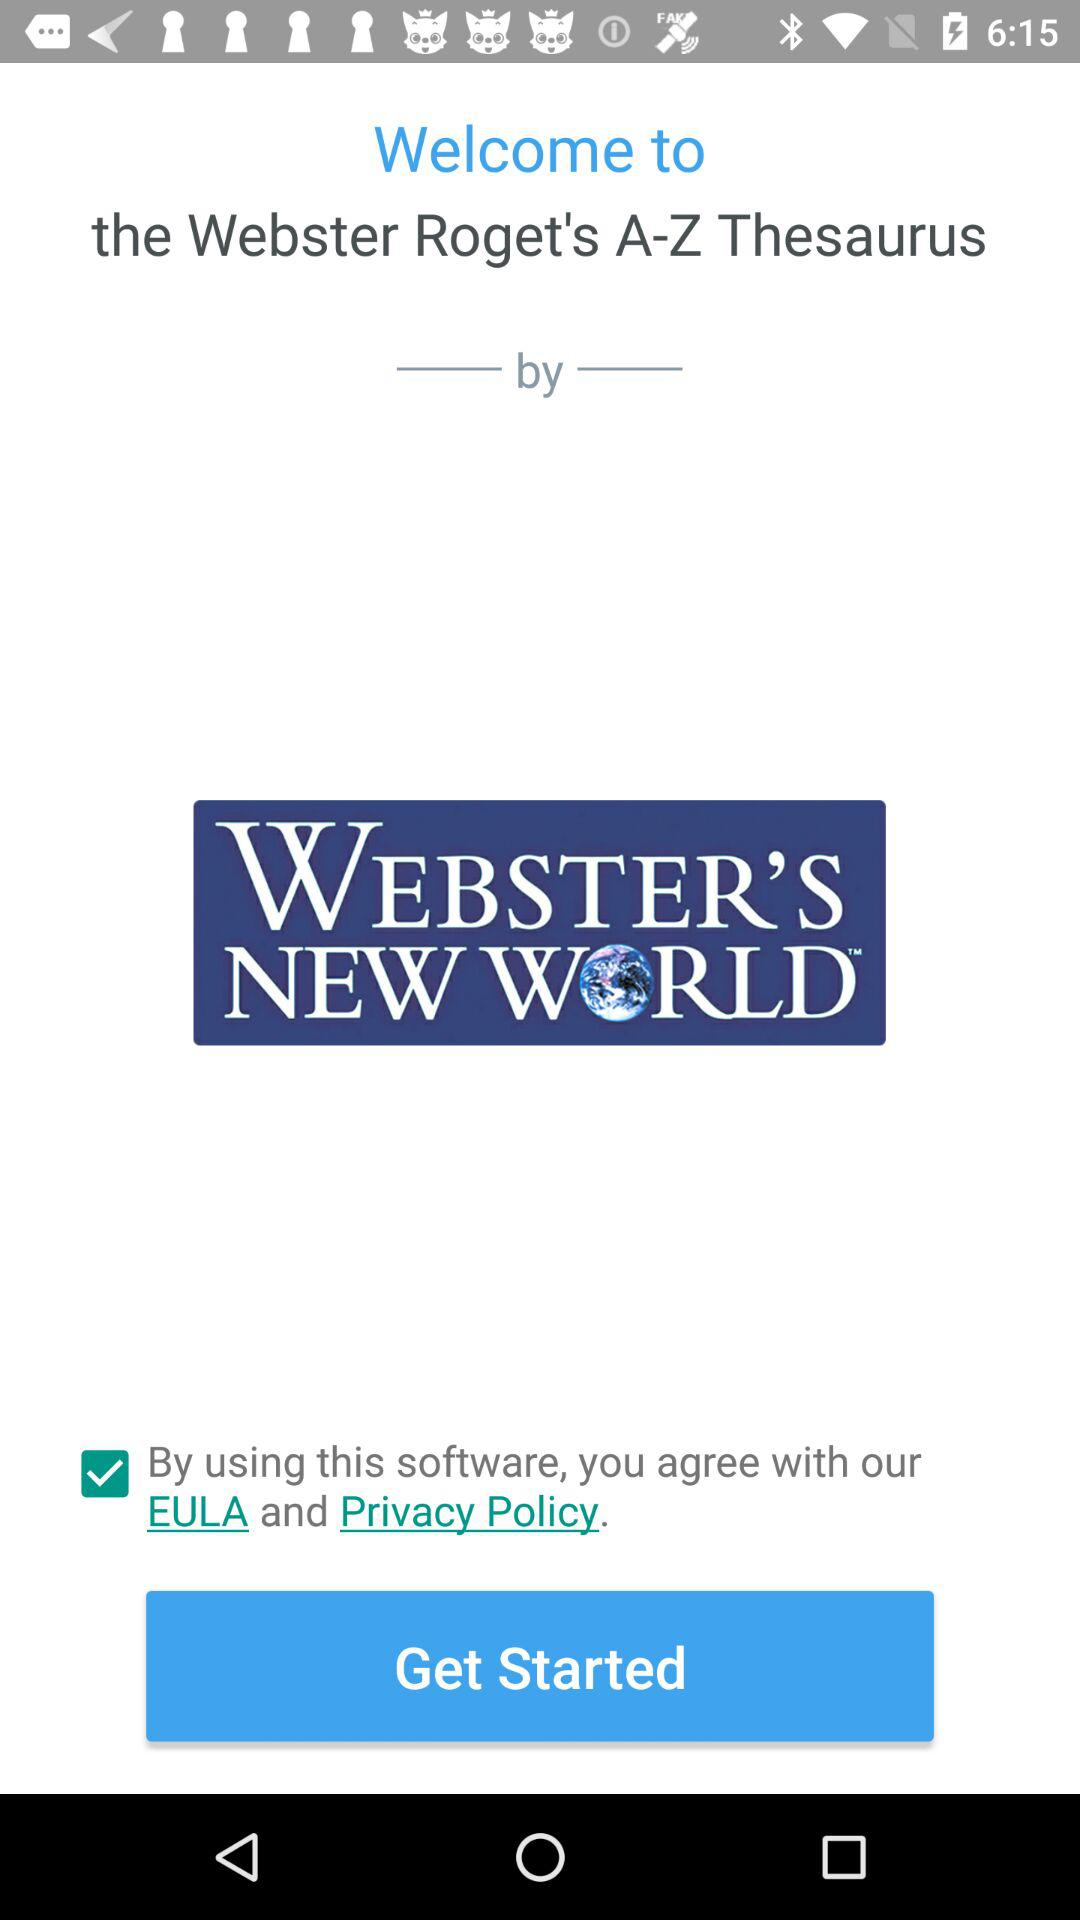What is the status of the option that includes agreement to the "EULA" and "Privacy Policy"? The status is "on". 